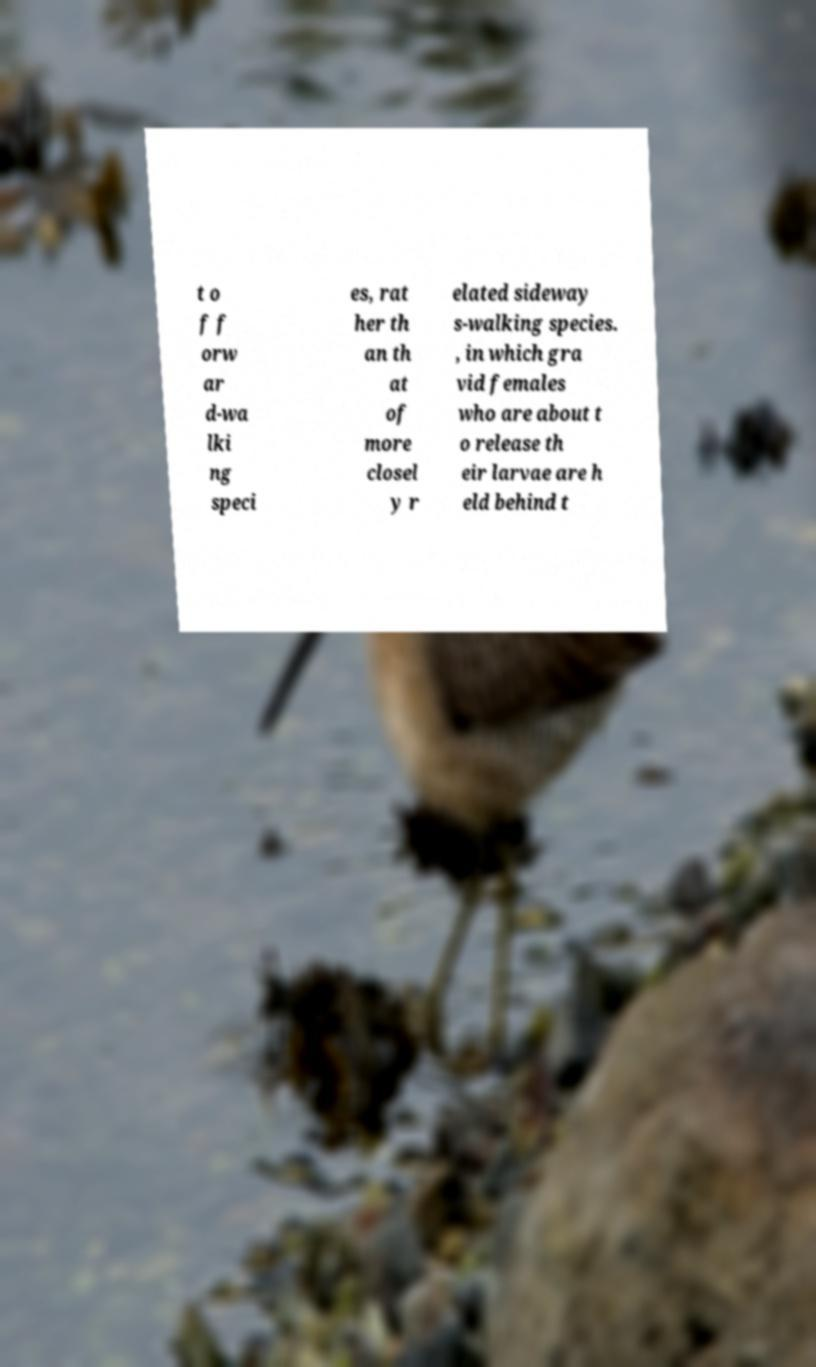Can you read and provide the text displayed in the image?This photo seems to have some interesting text. Can you extract and type it out for me? t o f f orw ar d-wa lki ng speci es, rat her th an th at of more closel y r elated sideway s-walking species. , in which gra vid females who are about t o release th eir larvae are h eld behind t 